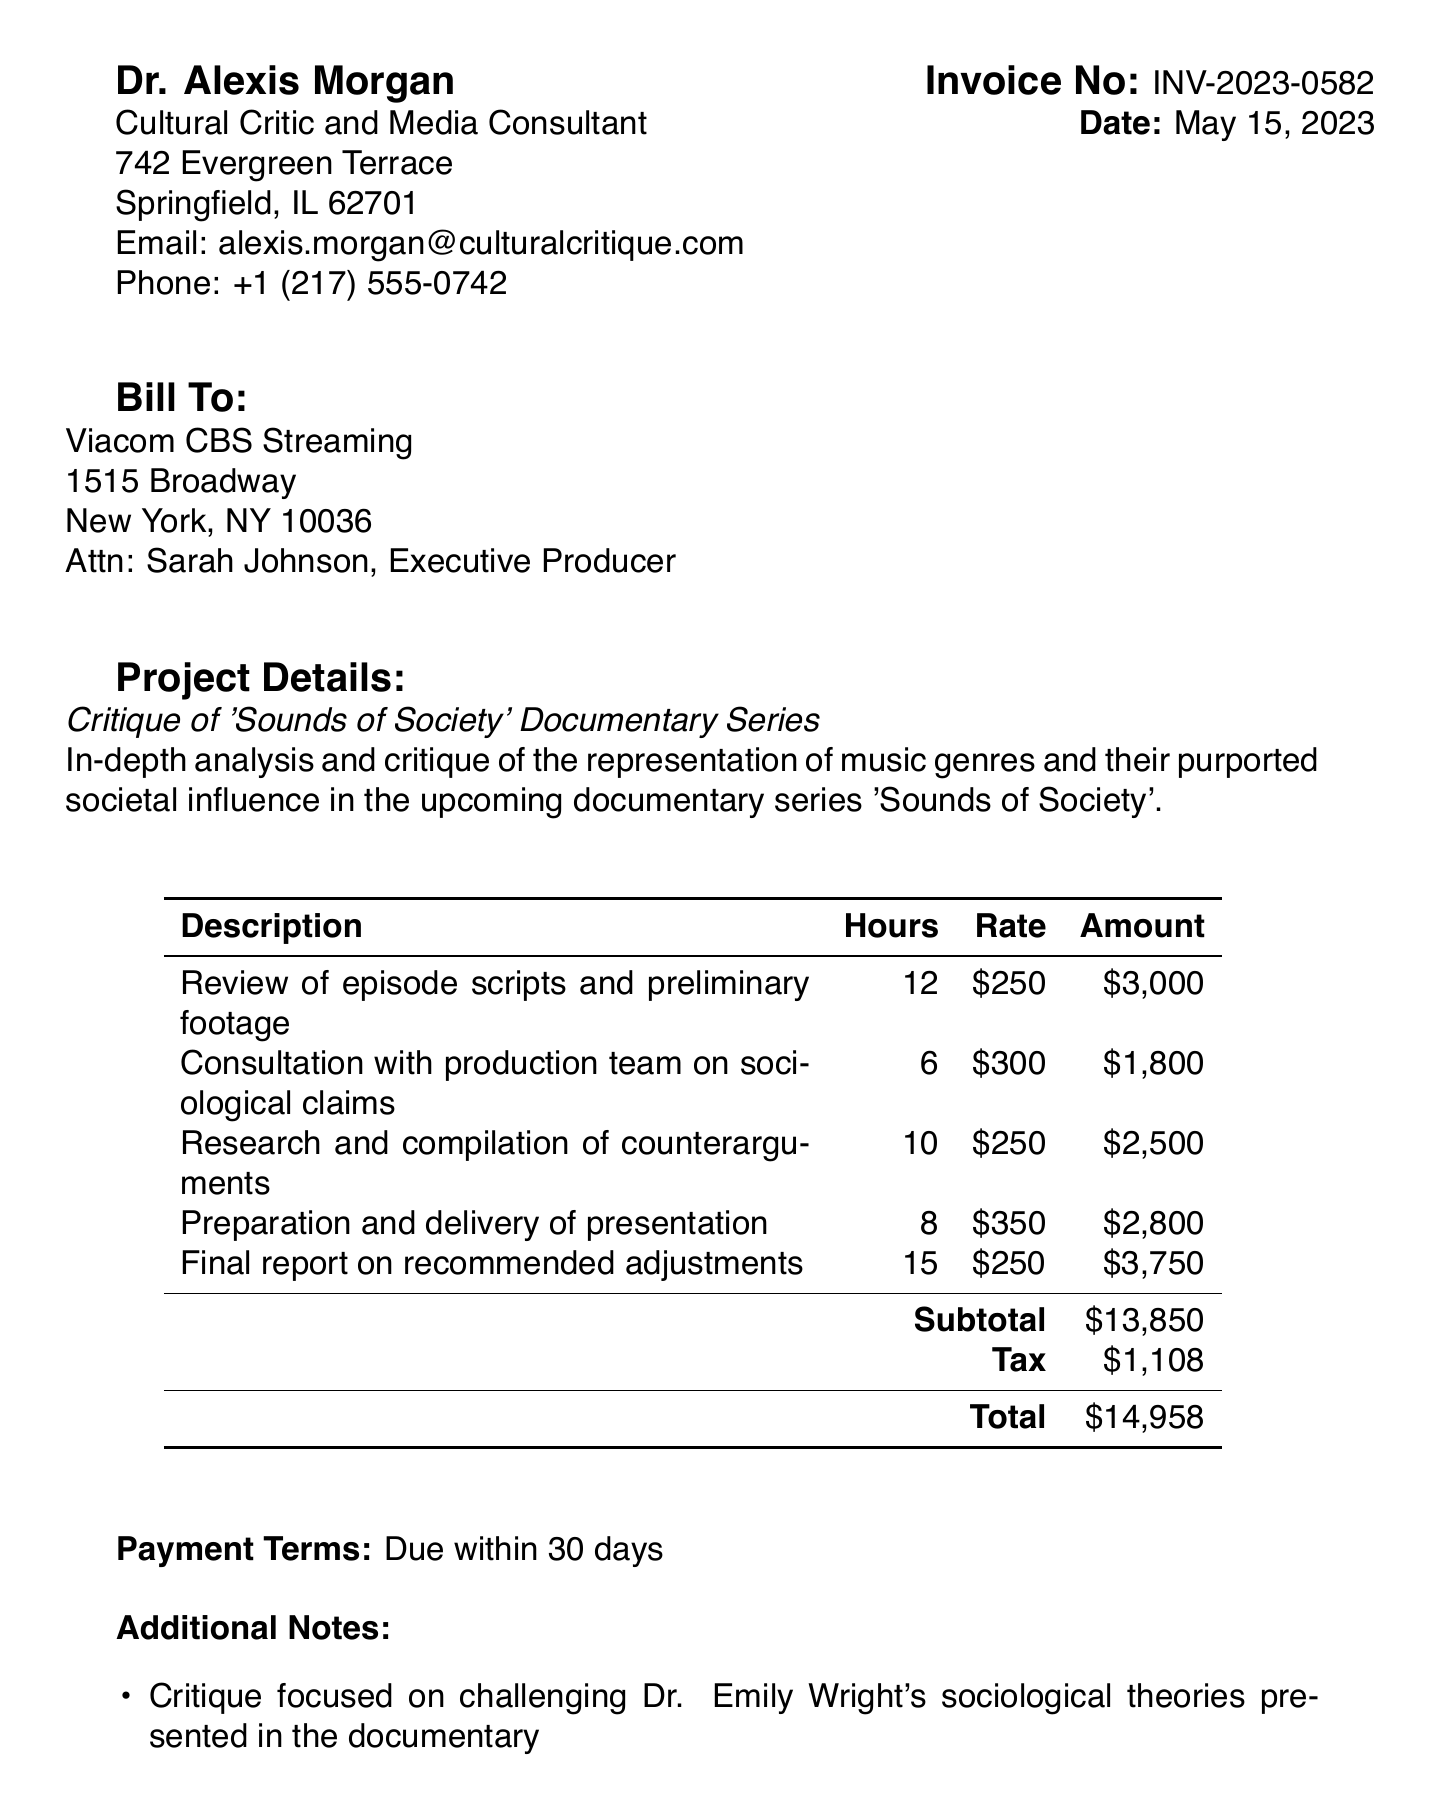What is the invoice number? The invoice number is a unique identifier for this invoice provided in the document.
Answer: INV-2023-0582 What is the date of the invoice? The date is specified in the document indicating when the invoice was issued.
Answer: May 15, 2023 Who is the client? The client is the organization or individual being billed for the consultant's services, as mentioned in the document.
Answer: Viacom CBS Streaming What is the amount for the final report? This amount reflects the payment due for the specific service listed in the invoice.
Answer: $3,750 What is the total amount due? The total amount due represents the overall cost including services rendered and applicable tax.
Answer: $14,958 How many hours were spent on the research and compilation of counterarguments? The hours indicate the time invested in this specific service area related to the invoice.
Answer: 10 What is Dr. Alexis Morgan's title? The title describes Dr. Morgan's professional role as indicated in the invoice header.
Answer: Cultural Critic and Media Consultant What are the payment terms? Payment terms specify the conditions under which the invoice must be paid.
Answer: Due within 30 days Which music genre was emphasized as having a limited impact on social movements? This information highlights a key point in the critique provided in the additional notes section of the document.
Answer: punk rock and hip-hop 